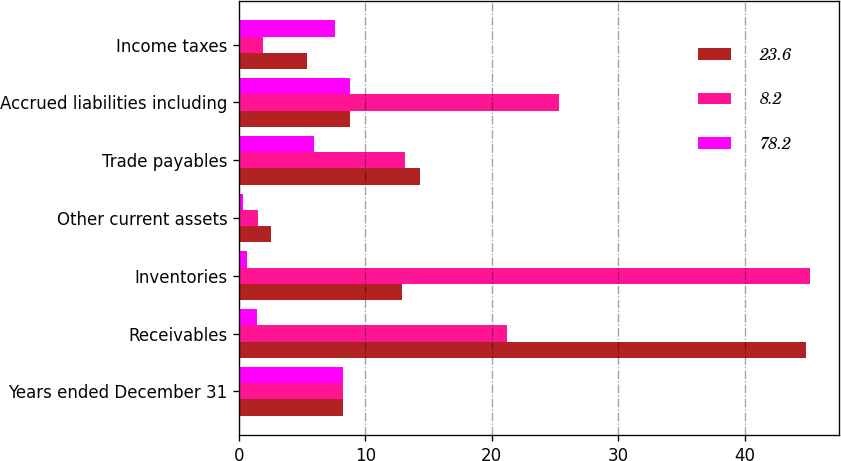Convert chart to OTSL. <chart><loc_0><loc_0><loc_500><loc_500><stacked_bar_chart><ecel><fcel>Years ended December 31<fcel>Receivables<fcel>Inventories<fcel>Other current assets<fcel>Trade payables<fcel>Accrued liabilities including<fcel>Income taxes<nl><fcel>23.6<fcel>8.2<fcel>44.9<fcel>12.9<fcel>2.5<fcel>14.3<fcel>8.8<fcel>5.4<nl><fcel>8.2<fcel>8.2<fcel>21.2<fcel>45.2<fcel>1.5<fcel>13.1<fcel>25.3<fcel>1.9<nl><fcel>78.2<fcel>8.2<fcel>1.4<fcel>0.6<fcel>0.3<fcel>5.9<fcel>8.8<fcel>7.6<nl></chart> 